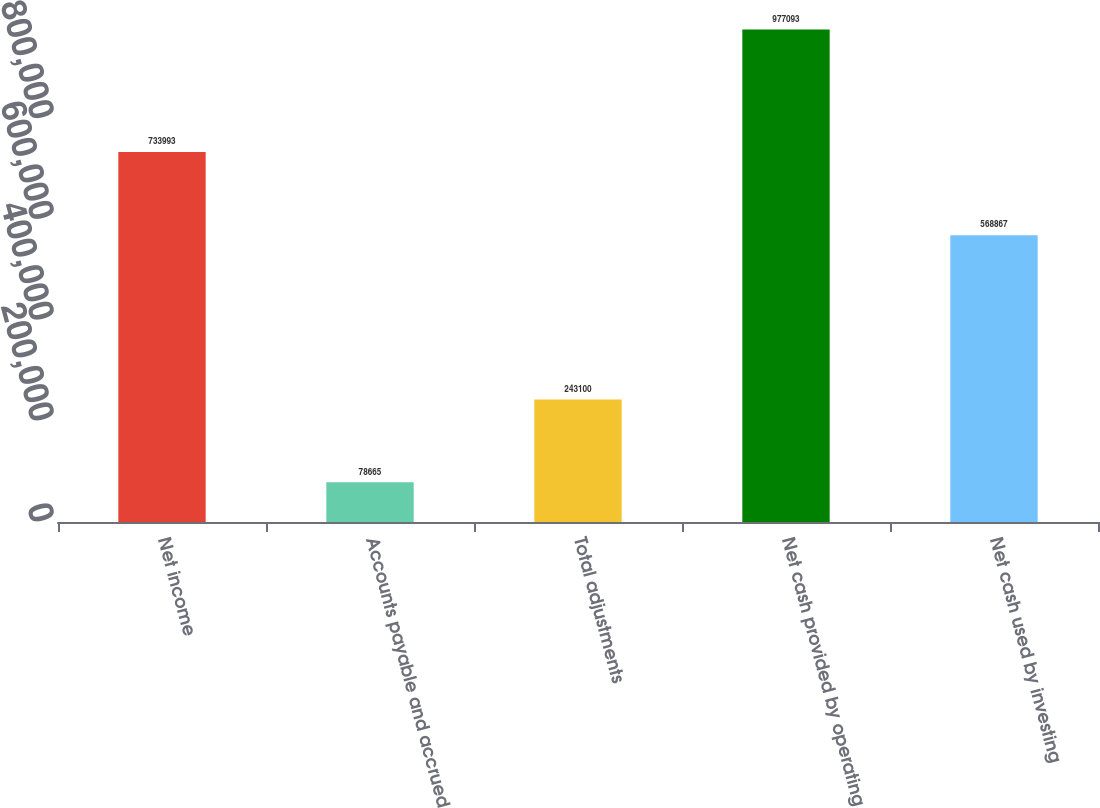Convert chart. <chart><loc_0><loc_0><loc_500><loc_500><bar_chart><fcel>Net income<fcel>Accounts payable and accrued<fcel>Total adjustments<fcel>Net cash provided by operating<fcel>Net cash used by investing<nl><fcel>733993<fcel>78665<fcel>243100<fcel>977093<fcel>568867<nl></chart> 